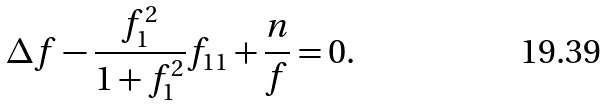<formula> <loc_0><loc_0><loc_500><loc_500>& \Delta f - \frac { f _ { 1 } ^ { 2 } } { 1 + f _ { 1 } ^ { 2 } } f _ { 1 1 } + \frac { n } { f } = 0 .</formula> 